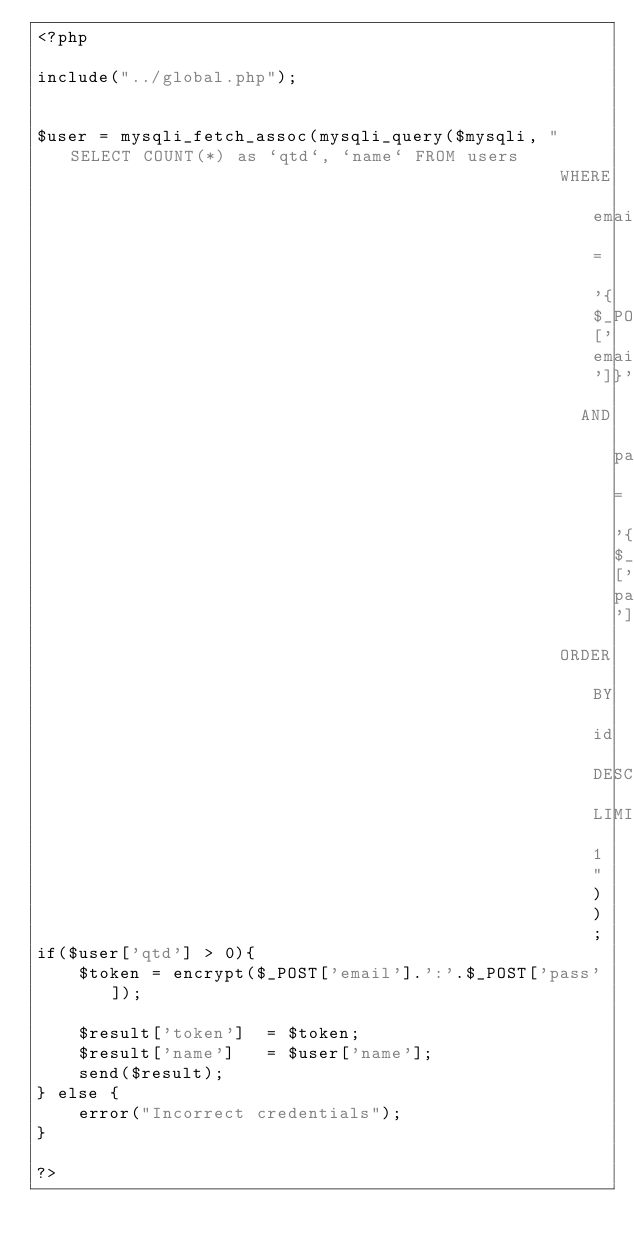<code> <loc_0><loc_0><loc_500><loc_500><_PHP_><?php

include("../global.php");


$user = mysqli_fetch_assoc(mysqli_query($mysqli, "SELECT COUNT(*) as `qtd`, `name` FROM users 
                                                  WHERE email = '{$_POST['email']}' 
                                                    AND pass = '{$_POST['pass']}' 
                                                  ORDER BY id DESC LIMIT 1"));
if($user['qtd'] > 0){
    $token = encrypt($_POST['email'].':'.$_POST['pass']);

    $result['token']  = $token;
    $result['name']   = $user['name'];
    send($result);
} else {
    error("Incorrect credentials");
}

?></code> 